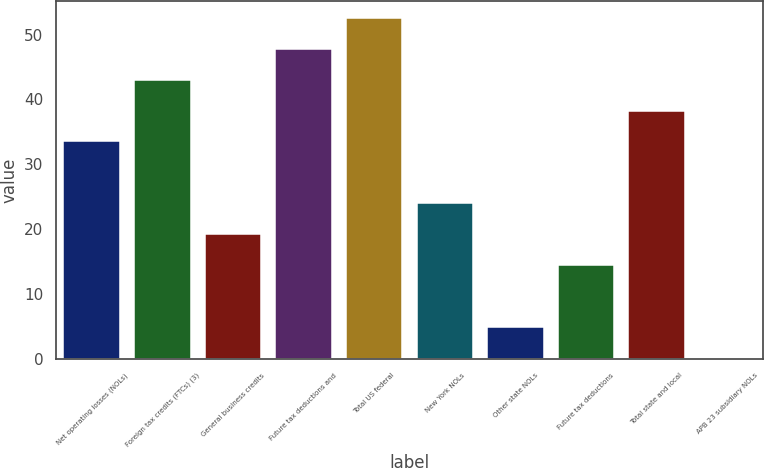Convert chart. <chart><loc_0><loc_0><loc_500><loc_500><bar_chart><fcel>Net operating losses (NOLs)<fcel>Foreign tax credits (FTCs) (3)<fcel>General business credits<fcel>Future tax deductions and<fcel>Total US federal<fcel>New York NOLs<fcel>Other state NOLs<fcel>Future tax deductions<fcel>Total state and local<fcel>APB 23 subsidiary NOLs<nl><fcel>33.52<fcel>43.04<fcel>19.24<fcel>47.8<fcel>52.56<fcel>24<fcel>4.96<fcel>14.48<fcel>38.28<fcel>0.2<nl></chart> 